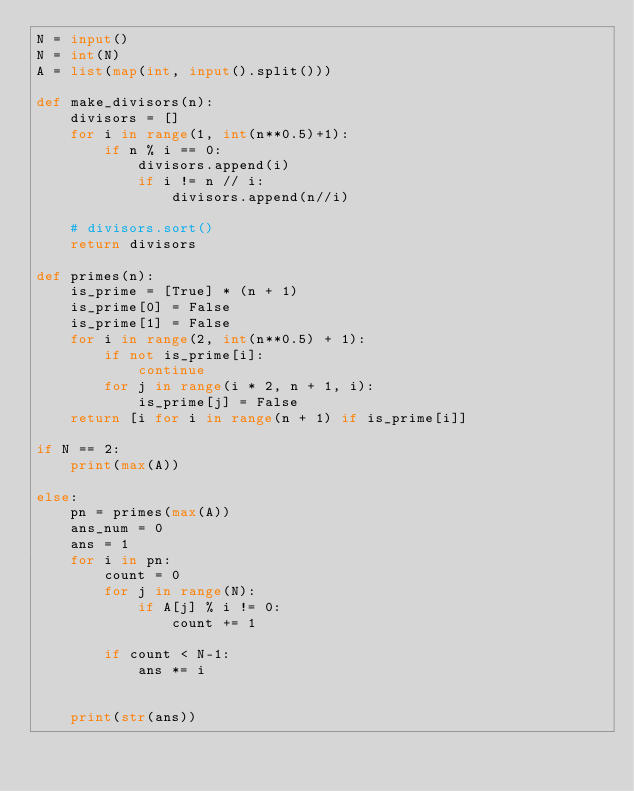<code> <loc_0><loc_0><loc_500><loc_500><_Python_>N = input()
N = int(N)
A = list(map(int, input().split()))

def make_divisors(n):
    divisors = []
    for i in range(1, int(n**0.5)+1):
        if n % i == 0:
            divisors.append(i)
            if i != n // i:
                divisors.append(n//i)

    # divisors.sort()
    return divisors

def primes(n):
    is_prime = [True] * (n + 1)
    is_prime[0] = False
    is_prime[1] = False
    for i in range(2, int(n**0.5) + 1):
        if not is_prime[i]:
            continue
        for j in range(i * 2, n + 1, i):
            is_prime[j] = False
    return [i for i in range(n + 1) if is_prime[i]]

if N == 2:
    print(max(A))

else:
    pn = primes(max(A))
    ans_num = 0
    ans = 1
    for i in pn:
        count = 0
        for j in range(N):
            if A[j] % i != 0:
                count += 1
        
        if count < N-1:
            ans *= i


    print(str(ans))</code> 